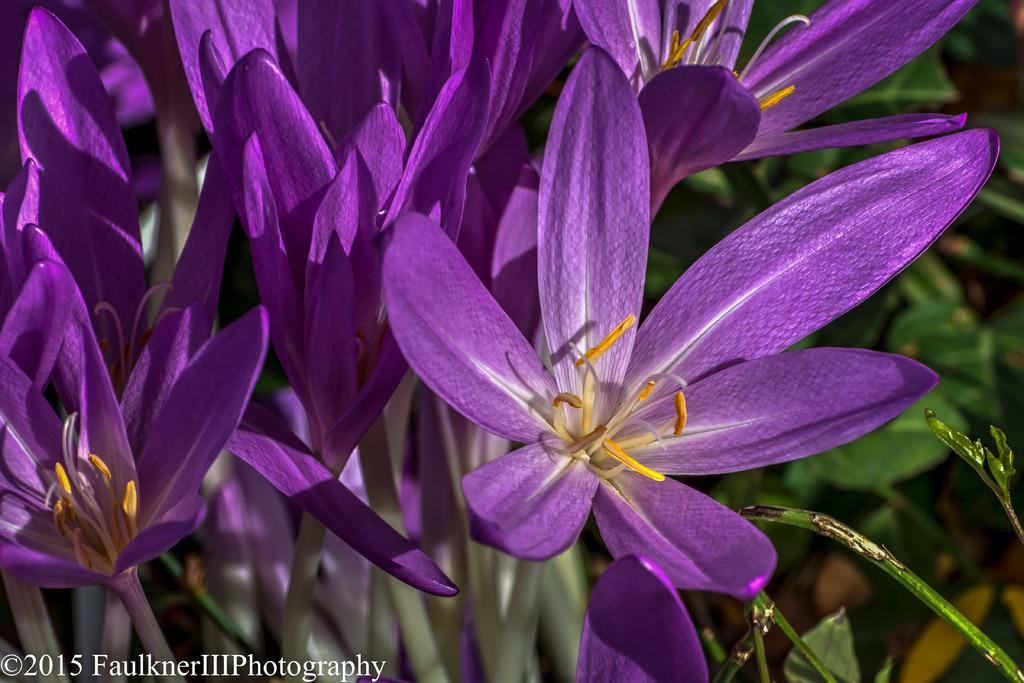How would you summarize this image in a sentence or two? In this image I can see few flowers which are violet, white and yellow in color. In the background I can see few plants. 